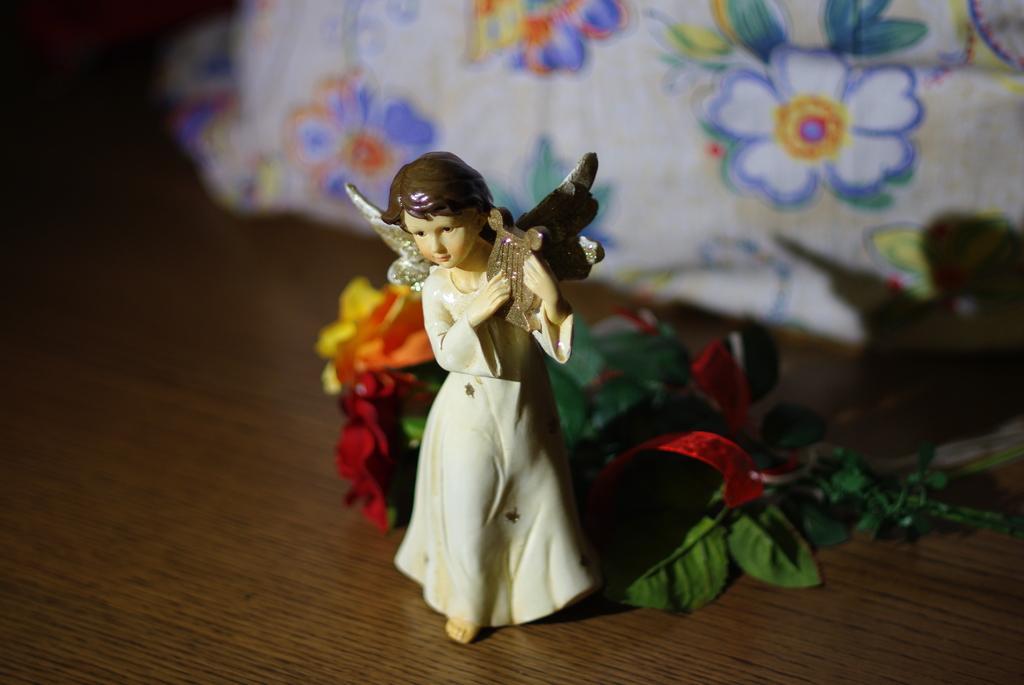In one or two sentences, can you explain what this image depicts? In the center of the image there is a toy and flowers on the table. In the background of the image there is a cloth with flowers on it. 